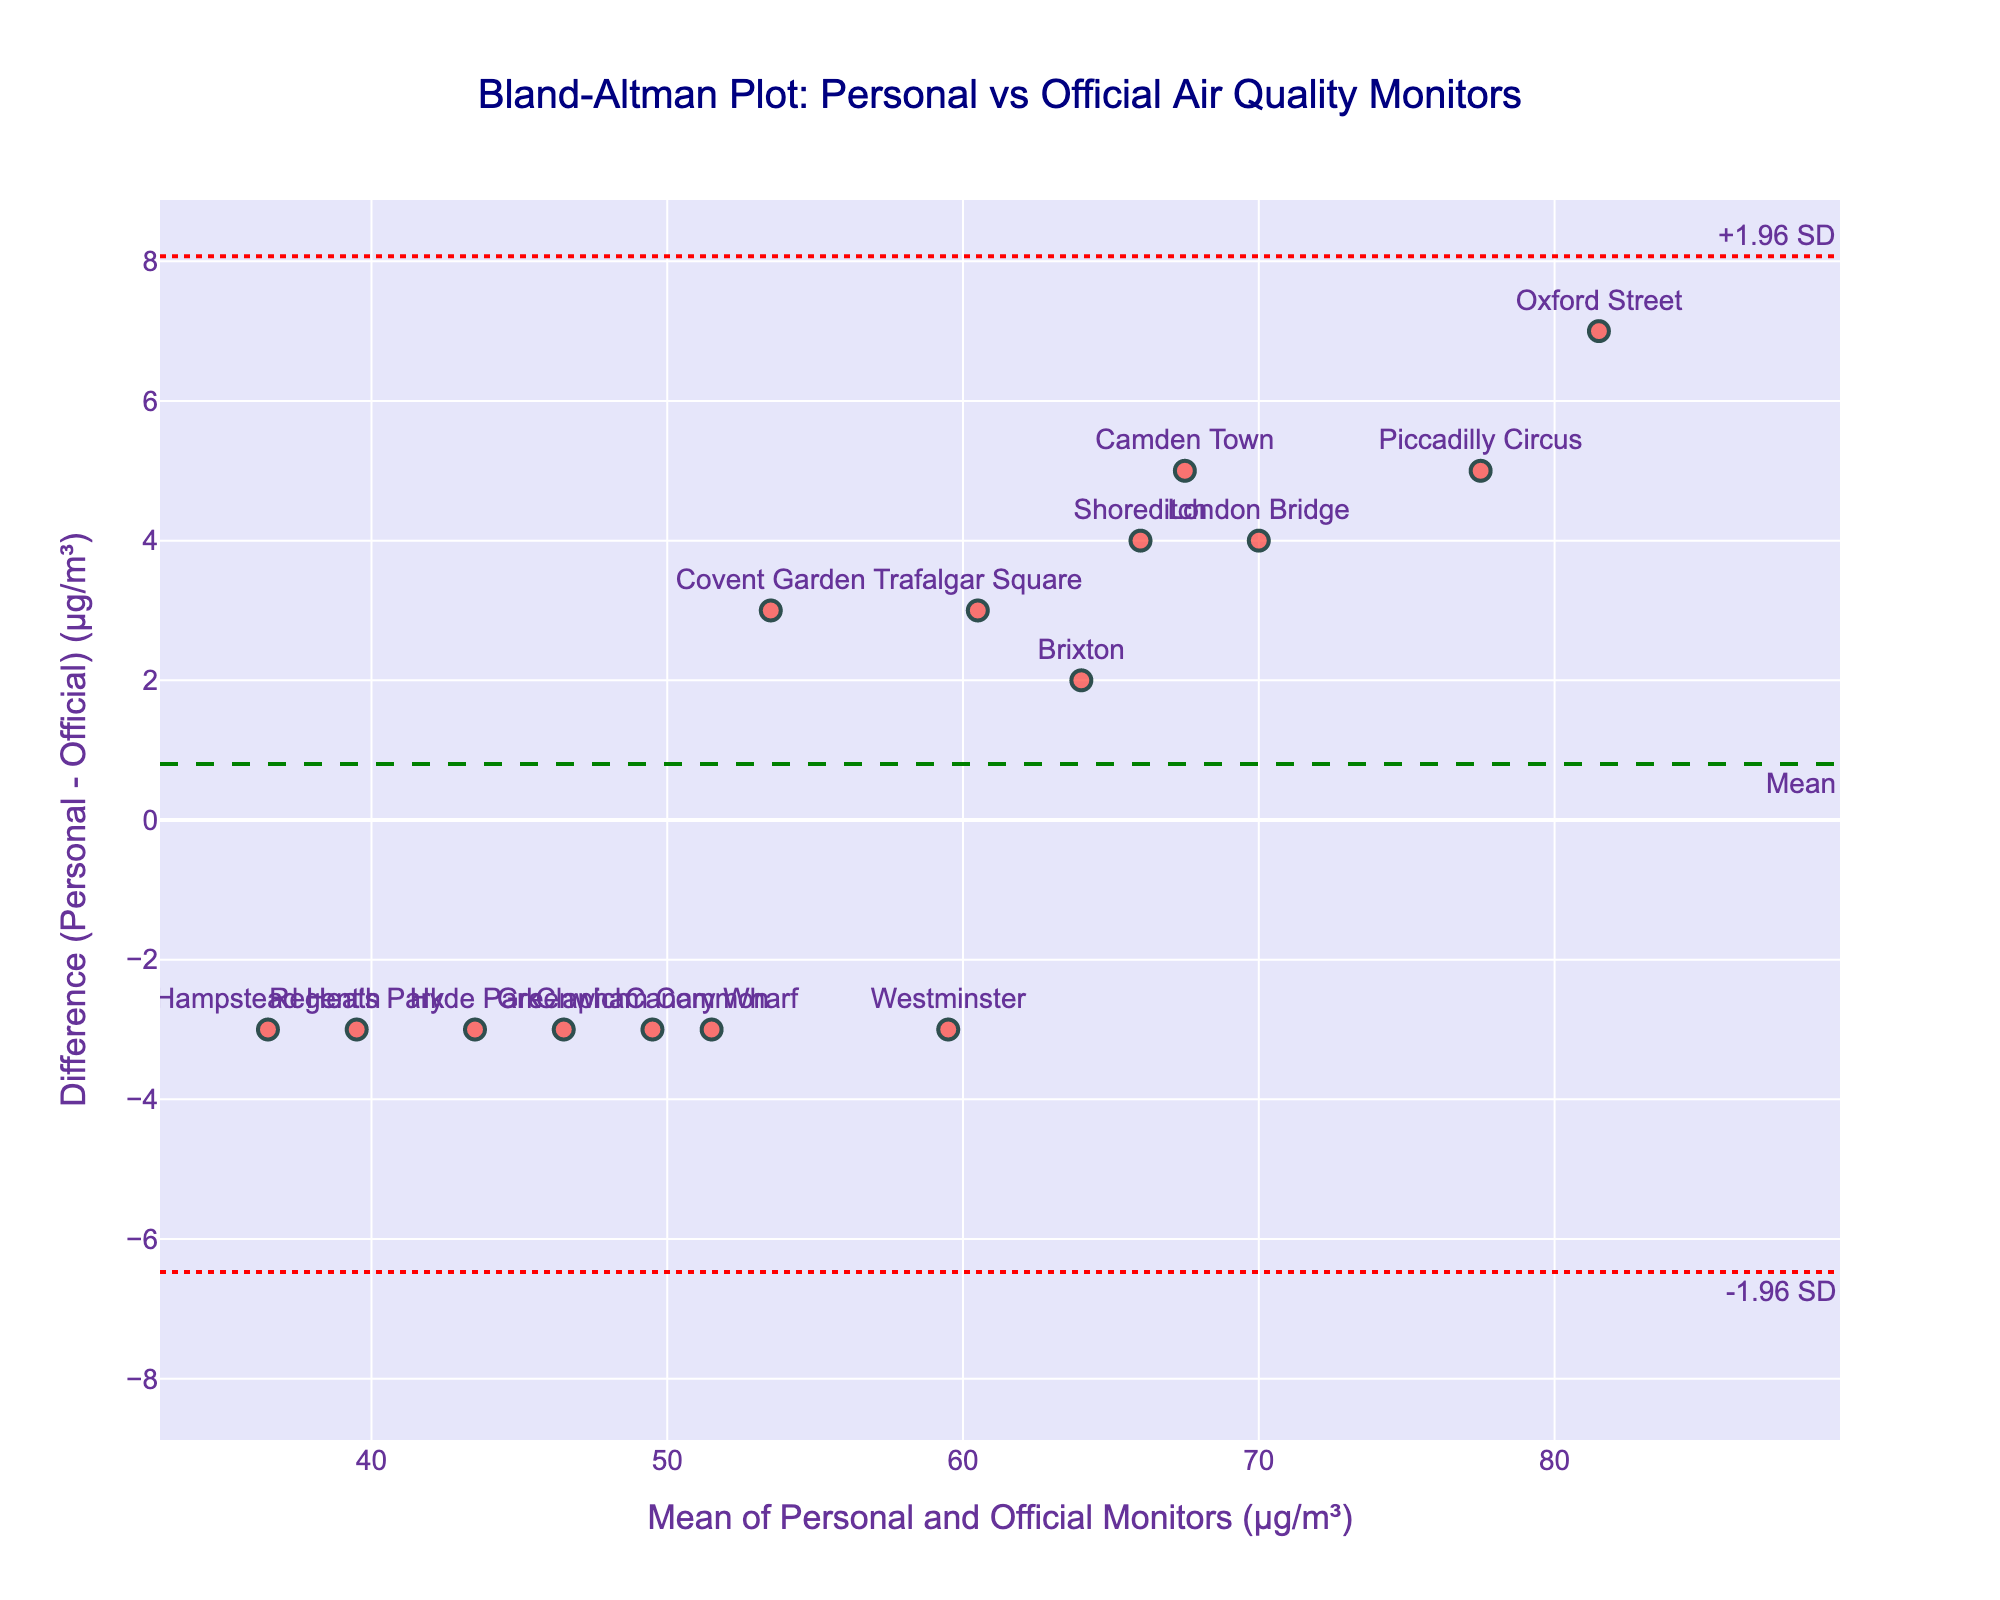How many data points are plotted on the figure? Count each marker in the scatter plot. There are 15 labeled locations, so there are 15 data points.
Answer: 15 What does the green dashed line represent? The green dashed line indicates the mean difference between the personal monitor and the official monitor readings.
Answer: Mean difference What are the approximate values for the upper and lower limits of agreement? The limits of agreement are represented by the red dotted lines. The upper limit is around 15 µg/m³ and the lower limit is around -15 µg/m³, based on the y-axis values where the lines are positioned.
Answer: 15 µg/m³ and -15 µg/m³ Which location has the highest difference between Personal and Official Monitor readings, and what is that difference? Identify the point farthest from the zero line. Oxford Street appears to be the highest. The exact difference can be found by checking its y-axis coordinate which is around 7 µg/m³.
Answer: Oxford Street, 7 µg/m³ Are there any data points where the Personal Monitor reading is equal to the Official Monitor reading? Compare the difference values on the y-axis to zero. If a point lies exactly on the zero line, the readings are equal. There are no points directly on the zero line in this plot.
Answer: No What can you infer about the overall accuracy of personal air quality monitors compared to the official city monitors? Look at the mean difference (green line) which is close to zero, and observe the dispersion around it (within upper and lower limits). This suggests personal monitors are generally accurate but with some variability.
Answer: Generally accurate with some variability Which location among Trafalgar Square, Camden Town, and Covent Garden shows the smallest difference between the two monitor readings? Check the y-axis values for these locations. Covent Garden has the smallest difference as it is closest to the zero line with a difference around 3 µg/m³.
Answer: Covent Garden Do any of the locations show a negative difference between Personal and Official Monitor readings? If so, name one. Look for points below the zero line (negative y-axis). Hampstead Heath shows a negative difference.
Answer: Hampstead Heath Which monitor (Personal or Official) tends to have slightly higher readings on average, based on the plot? Look at the position of most points relative to the zero line. Most points are slightly above the zero line, suggesting the Personal Monitor tends to read higher.
Answer: Personal Monitor What is the mean of the readings from the Personal and Official Monitors for Westminster? Identify Westminster's mean value on the x-axis. Since the difference is small and it's near the center, calculate the average of Personal (58) and Official (61). (58 + 61)/2 = 59.5.
Answer: 59.5 µg/m³ 